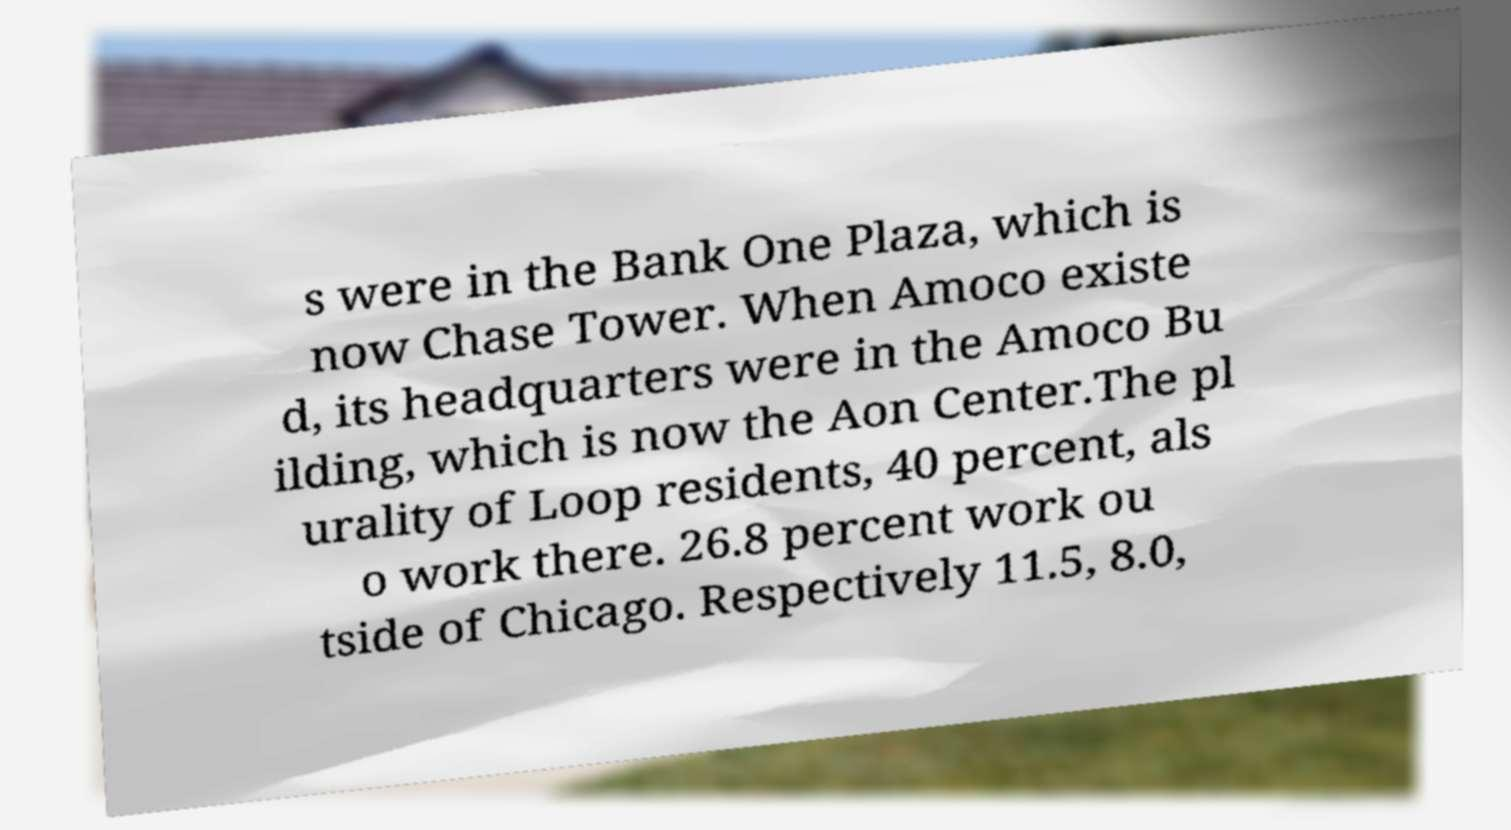What messages or text are displayed in this image? I need them in a readable, typed format. s were in the Bank One Plaza, which is now Chase Tower. When Amoco existe d, its headquarters were in the Amoco Bu ilding, which is now the Aon Center.The pl urality of Loop residents, 40 percent, als o work there. 26.8 percent work ou tside of Chicago. Respectively 11.5, 8.0, 